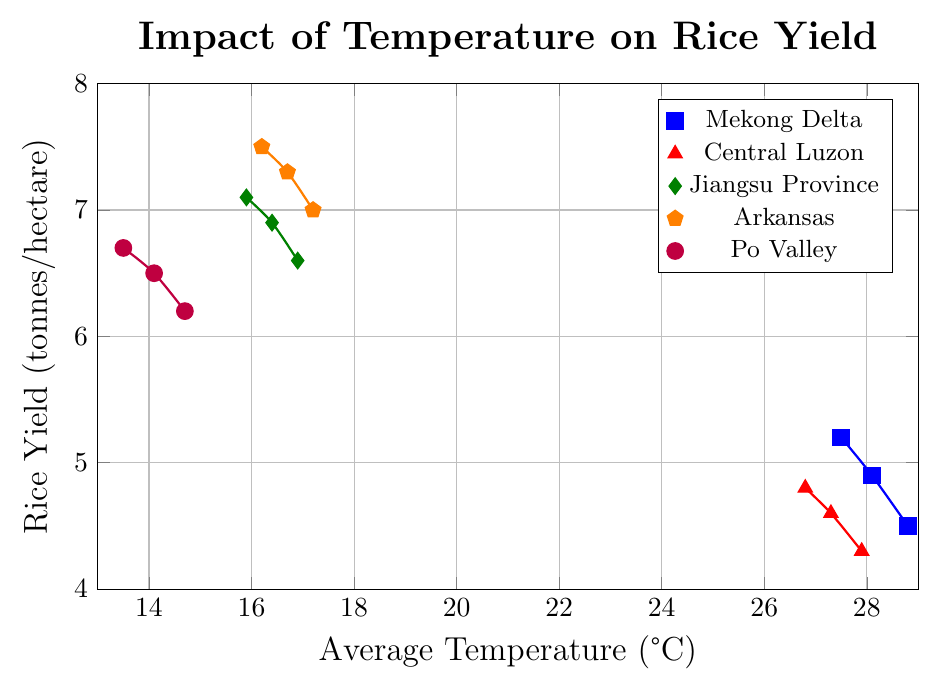What trend does the line for the Mekong Delta region show between 2010 and 2020? The line for the Mekong Delta region (blue) shows a decrease in rice yield from 5.2 tonnes/hectare to 4.5 tonnes/hectare as the average temperature increases from 27.5°C to 28.8°C.
Answer: The rice yield decreases as temperature increases Which region had the highest rice yield in 2020? In 2020, the region with the highest rice yield can be identified by looking at the tallest point on the y-axis within that year. Jiangsu Province (green) shows the highest yield at 6.6 tonnes/hectare.
Answer: Jiangsu Province How does the rice yield in Arkansas compare to Po Valley at a similar temperature in 2020? In 2020, Arkansas had an average temperature of 17.2°C and a rice yield of 7.0 tonnes/hectare, whereas Po Valley had an average temperature of 14.7°C and a yield of 6.2 tonnes/hectare. Arkansas, despite a slightly higher temperature, had a higher yield.
Answer: Arkansas had a higher yield Which region shows the highest sensitivity to temperature changes based on the steepness of the slope of their line? The steepness of the slope indicates how sensitive the region is to temperature changes. From the lines, Mekong Delta (blue) and Central Luzon (red) show steeper slopes, suggesting higher sensitivity. However, Mekong Delta has the most noticeable yield decrease.
Answer: Mekong Delta Calculate the difference in average rice yield between Jiangsu Province and Central Luzon in 2015. In 2015, Jiangsu Province had a rice yield of 6.9 tonnes/hectare and Central Luzon had 4.6 tonnes/hectare. The difference is 6.9 - 4.6.
Answer: 2.3 tonnes/hectare Is there any region where the yield increased significantly over the period from 2010 to 2020? By examining the lines, we can see that none of the regions show an increase in rice yield over the period from 2010 to 2020. All lines show either a decrease or very minimal change towards a decrease.
Answer: No Which region begins with the lowest rice yield in 2010 and what is it? By looking at the data points for 2010, Central Luzon (red) begins with the lowest rice yield at 4.8 tonnes/hectare.
Answer: Central Luzon, 4.8 tonnes/hectare By calculating the average change in yield per degree Celsius increase in temperature for Arkansas, what do you find? Arkansas had temperatures of 16.2°C in 2010 with a yield of 7.5 tonnes/hectare, 16.7°C in 2015 with 7.3 tonnes/hectare, and 17.2°C in 2020 with 7.0 tonnes/hectare. Calculate the changes: (7.5 - 7.3) / (16.7 - 16.2) = 0.2 / 0.5 = 0.4 tonnes/hectare per °C. For the next period: (7.3 - 7.0) / (17.2 - 16.7) = 0.3 / 0.5 = 0.6 tonnes/hectare per °C. Average of 0.4 and 0.6 is (0.4 + 0.6) / 2 = 0.5 tonnes/hectare per °C.
Answer: 0.5 tonnes/hectare per °C Which region had the least change in rice yield over the period from 2010 to 2020? By observing the vertical difference in the lines' respective end points in 2010 and 2020, Jiangsu Province (green) shows the least change in yield from 7.1 to 6.6 tonnes/hectare.
Answer: Jiangsu Province 